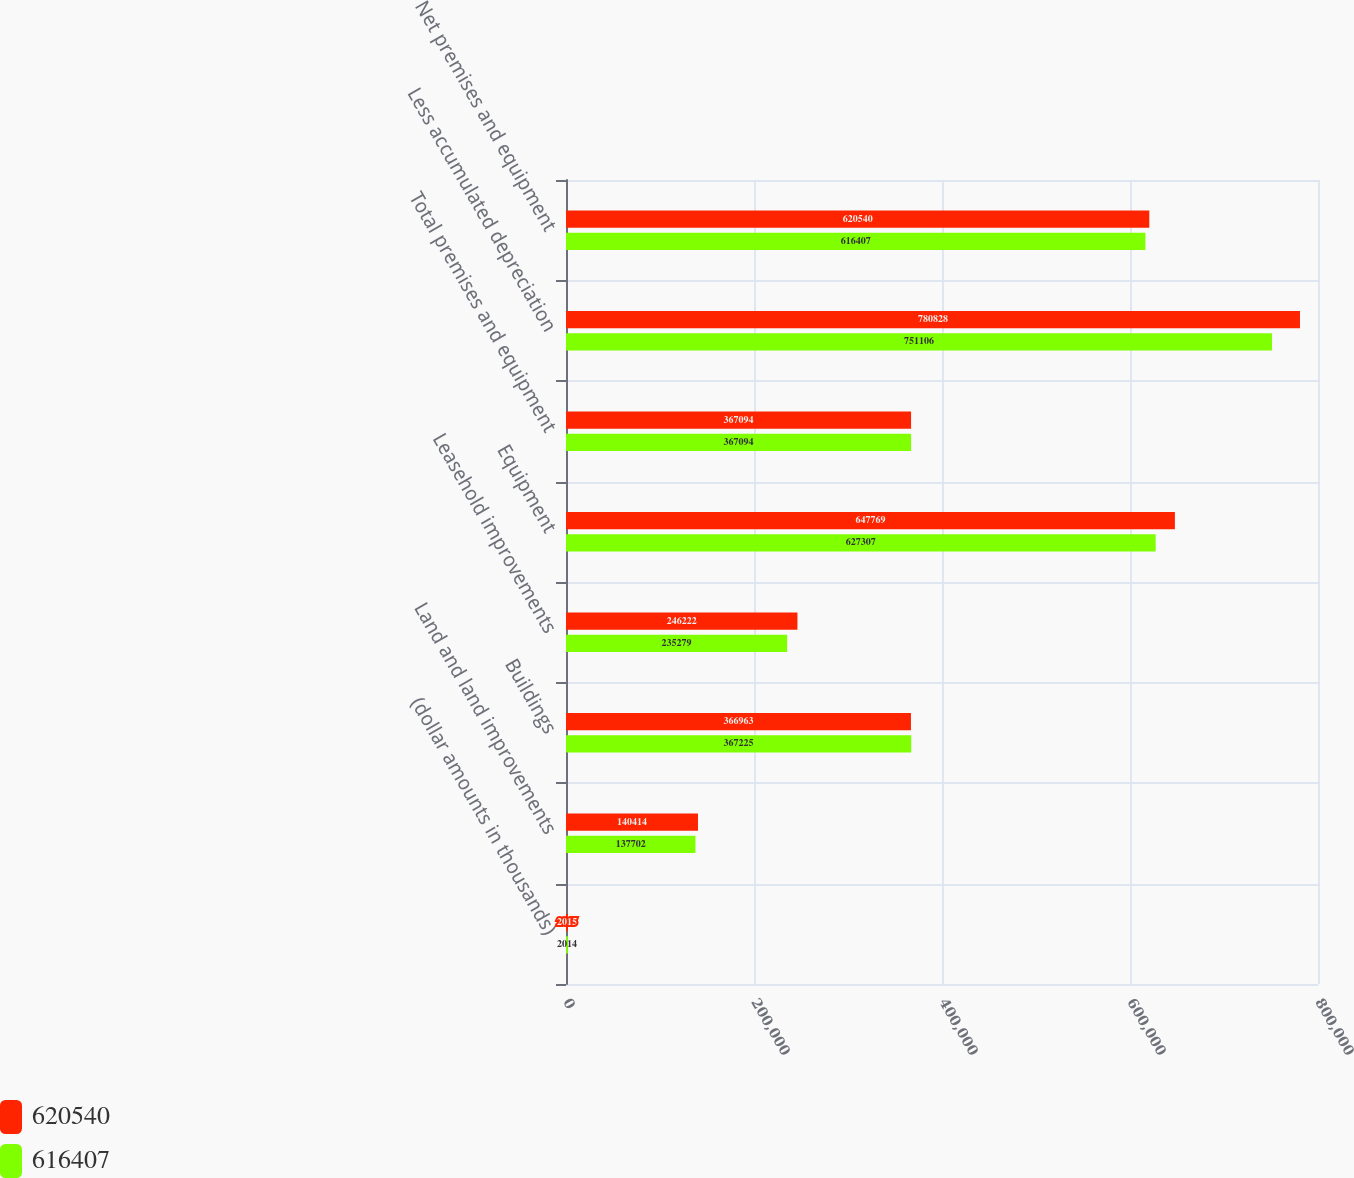Convert chart. <chart><loc_0><loc_0><loc_500><loc_500><stacked_bar_chart><ecel><fcel>(dollar amounts in thousands)<fcel>Land and land improvements<fcel>Buildings<fcel>Leasehold improvements<fcel>Equipment<fcel>Total premises and equipment<fcel>Less accumulated depreciation<fcel>Net premises and equipment<nl><fcel>620540<fcel>2015<fcel>140414<fcel>366963<fcel>246222<fcel>647769<fcel>367094<fcel>780828<fcel>620540<nl><fcel>616407<fcel>2014<fcel>137702<fcel>367225<fcel>235279<fcel>627307<fcel>367094<fcel>751106<fcel>616407<nl></chart> 